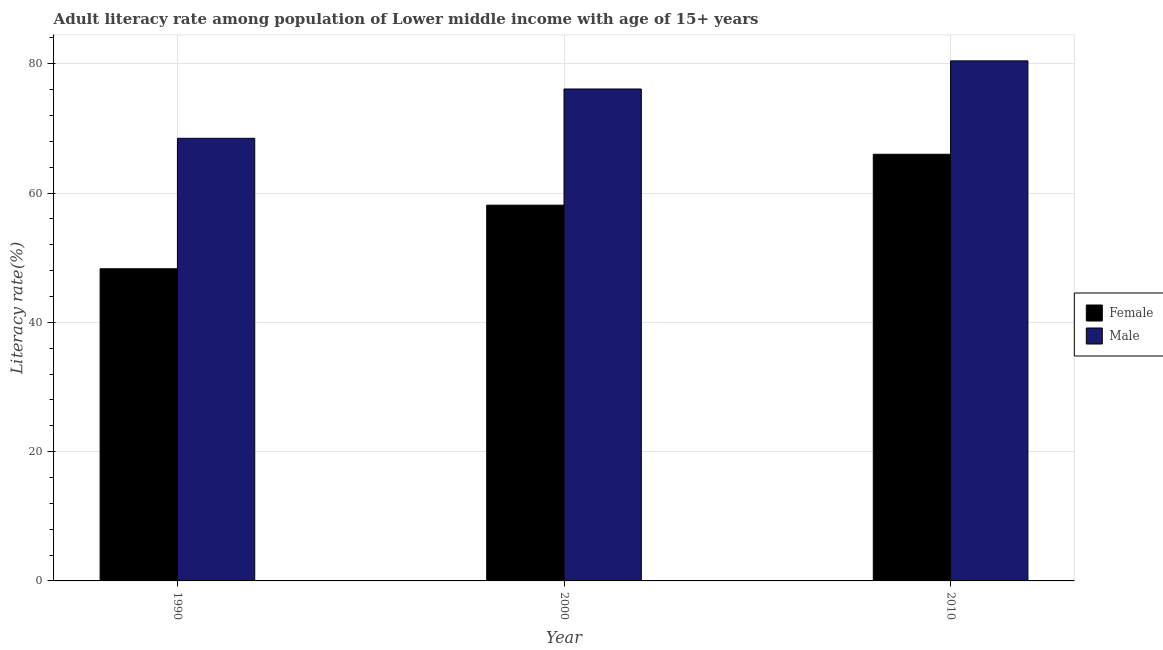Are the number of bars per tick equal to the number of legend labels?
Your answer should be compact. Yes. Are the number of bars on each tick of the X-axis equal?
Provide a succinct answer. Yes. How many bars are there on the 2nd tick from the right?
Offer a very short reply. 2. In how many cases, is the number of bars for a given year not equal to the number of legend labels?
Ensure brevity in your answer.  0. What is the female adult literacy rate in 2010?
Your response must be concise. 66.01. Across all years, what is the maximum male adult literacy rate?
Keep it short and to the point. 80.46. Across all years, what is the minimum female adult literacy rate?
Provide a succinct answer. 48.3. In which year was the female adult literacy rate maximum?
Your answer should be very brief. 2010. What is the total female adult literacy rate in the graph?
Your response must be concise. 172.44. What is the difference between the male adult literacy rate in 1990 and that in 2010?
Your answer should be compact. -11.98. What is the difference between the female adult literacy rate in 2010 and the male adult literacy rate in 2000?
Your response must be concise. 7.87. What is the average male adult literacy rate per year?
Your answer should be very brief. 75.01. What is the ratio of the female adult literacy rate in 1990 to that in 2010?
Provide a short and direct response. 0.73. Is the female adult literacy rate in 1990 less than that in 2010?
Keep it short and to the point. Yes. What is the difference between the highest and the second highest female adult literacy rate?
Provide a succinct answer. 7.87. What is the difference between the highest and the lowest female adult literacy rate?
Your answer should be compact. 17.71. In how many years, is the female adult literacy rate greater than the average female adult literacy rate taken over all years?
Keep it short and to the point. 2. What does the 1st bar from the left in 2000 represents?
Offer a terse response. Female. How many bars are there?
Provide a succinct answer. 6. What is the difference between two consecutive major ticks on the Y-axis?
Your response must be concise. 20. Are the values on the major ticks of Y-axis written in scientific E-notation?
Your answer should be compact. No. Does the graph contain grids?
Provide a succinct answer. Yes. Where does the legend appear in the graph?
Your response must be concise. Center right. How many legend labels are there?
Your answer should be compact. 2. How are the legend labels stacked?
Offer a terse response. Vertical. What is the title of the graph?
Your response must be concise. Adult literacy rate among population of Lower middle income with age of 15+ years. What is the label or title of the Y-axis?
Your response must be concise. Literacy rate(%). What is the Literacy rate(%) in Female in 1990?
Offer a terse response. 48.3. What is the Literacy rate(%) in Male in 1990?
Offer a very short reply. 68.47. What is the Literacy rate(%) of Female in 2000?
Provide a short and direct response. 58.14. What is the Literacy rate(%) of Male in 2000?
Make the answer very short. 76.11. What is the Literacy rate(%) of Female in 2010?
Ensure brevity in your answer.  66.01. What is the Literacy rate(%) in Male in 2010?
Keep it short and to the point. 80.46. Across all years, what is the maximum Literacy rate(%) in Female?
Provide a short and direct response. 66.01. Across all years, what is the maximum Literacy rate(%) of Male?
Offer a very short reply. 80.46. Across all years, what is the minimum Literacy rate(%) of Female?
Your response must be concise. 48.3. Across all years, what is the minimum Literacy rate(%) in Male?
Your answer should be very brief. 68.47. What is the total Literacy rate(%) in Female in the graph?
Keep it short and to the point. 172.44. What is the total Literacy rate(%) in Male in the graph?
Make the answer very short. 225.04. What is the difference between the Literacy rate(%) in Female in 1990 and that in 2000?
Your response must be concise. -9.84. What is the difference between the Literacy rate(%) of Male in 1990 and that in 2000?
Provide a short and direct response. -7.63. What is the difference between the Literacy rate(%) of Female in 1990 and that in 2010?
Offer a very short reply. -17.71. What is the difference between the Literacy rate(%) in Male in 1990 and that in 2010?
Your answer should be compact. -11.98. What is the difference between the Literacy rate(%) in Female in 2000 and that in 2010?
Make the answer very short. -7.87. What is the difference between the Literacy rate(%) in Male in 2000 and that in 2010?
Your answer should be compact. -4.35. What is the difference between the Literacy rate(%) in Female in 1990 and the Literacy rate(%) in Male in 2000?
Provide a short and direct response. -27.81. What is the difference between the Literacy rate(%) in Female in 1990 and the Literacy rate(%) in Male in 2010?
Offer a terse response. -32.16. What is the difference between the Literacy rate(%) in Female in 2000 and the Literacy rate(%) in Male in 2010?
Offer a very short reply. -22.32. What is the average Literacy rate(%) in Female per year?
Your answer should be compact. 57.48. What is the average Literacy rate(%) of Male per year?
Offer a terse response. 75.01. In the year 1990, what is the difference between the Literacy rate(%) in Female and Literacy rate(%) in Male?
Your response must be concise. -20.18. In the year 2000, what is the difference between the Literacy rate(%) of Female and Literacy rate(%) of Male?
Your answer should be compact. -17.97. In the year 2010, what is the difference between the Literacy rate(%) of Female and Literacy rate(%) of Male?
Provide a short and direct response. -14.45. What is the ratio of the Literacy rate(%) in Female in 1990 to that in 2000?
Keep it short and to the point. 0.83. What is the ratio of the Literacy rate(%) in Male in 1990 to that in 2000?
Make the answer very short. 0.9. What is the ratio of the Literacy rate(%) in Female in 1990 to that in 2010?
Your answer should be compact. 0.73. What is the ratio of the Literacy rate(%) of Male in 1990 to that in 2010?
Keep it short and to the point. 0.85. What is the ratio of the Literacy rate(%) of Female in 2000 to that in 2010?
Ensure brevity in your answer.  0.88. What is the ratio of the Literacy rate(%) in Male in 2000 to that in 2010?
Offer a very short reply. 0.95. What is the difference between the highest and the second highest Literacy rate(%) of Female?
Ensure brevity in your answer.  7.87. What is the difference between the highest and the second highest Literacy rate(%) of Male?
Your answer should be very brief. 4.35. What is the difference between the highest and the lowest Literacy rate(%) in Female?
Your answer should be compact. 17.71. What is the difference between the highest and the lowest Literacy rate(%) in Male?
Your answer should be very brief. 11.98. 